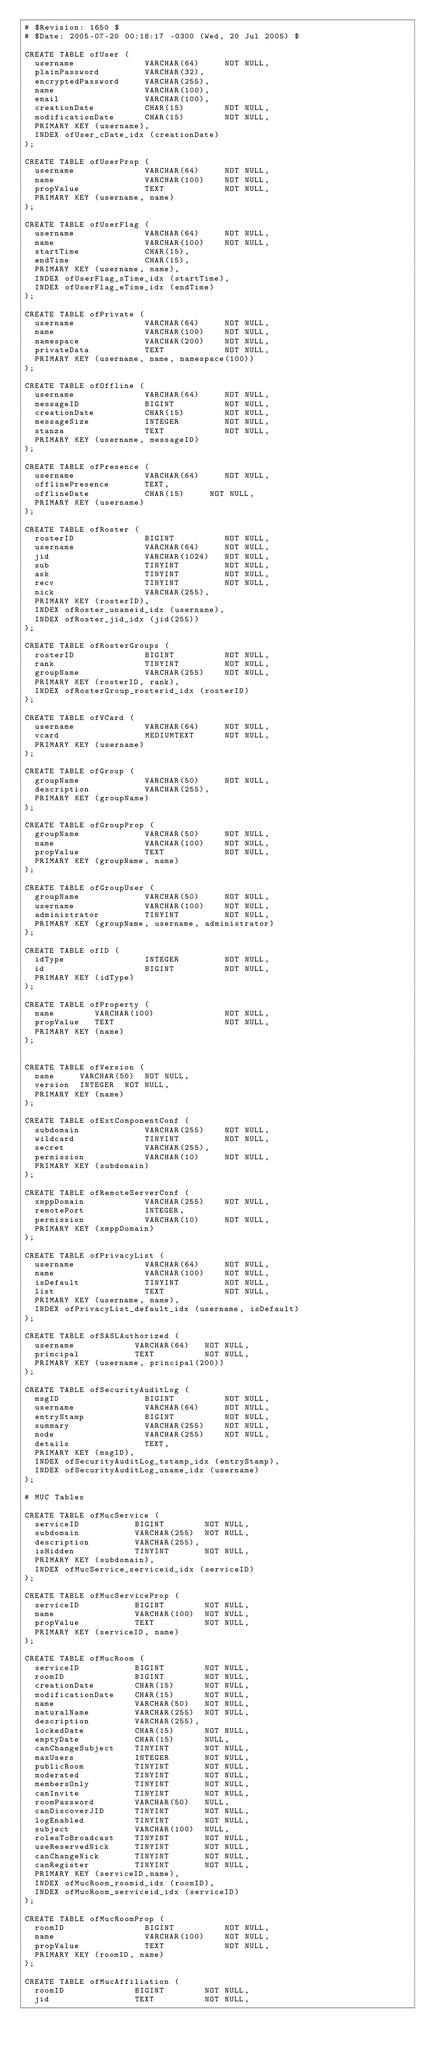Convert code to text. <code><loc_0><loc_0><loc_500><loc_500><_SQL_># $Revision: 1650 $
# $Date: 2005-07-20 00:18:17 -0300 (Wed, 20 Jul 2005) $

CREATE TABLE ofUser (
  username              VARCHAR(64)     NOT NULL,
  plainPassword         VARCHAR(32),
  encryptedPassword     VARCHAR(255),
  name                  VARCHAR(100),
  email                 VARCHAR(100),
  creationDate          CHAR(15)        NOT NULL,
  modificationDate      CHAR(15)        NOT NULL,
  PRIMARY KEY (username),
  INDEX ofUser_cDate_idx (creationDate)
);

CREATE TABLE ofUserProp (
  username              VARCHAR(64)     NOT NULL,
  name                  VARCHAR(100)    NOT NULL,
  propValue             TEXT            NOT NULL,
  PRIMARY KEY (username, name)
);

CREATE TABLE ofUserFlag (
  username              VARCHAR(64)     NOT NULL,
  name                  VARCHAR(100)    NOT NULL,
  startTime             CHAR(15),
  endTime               CHAR(15),
  PRIMARY KEY (username, name),
  INDEX ofUserFlag_sTime_idx (startTime),
  INDEX ofUserFlag_eTime_idx (endTime)
);

CREATE TABLE ofPrivate (
  username              VARCHAR(64)     NOT NULL,
  name                  VARCHAR(100)    NOT NULL,
  namespace             VARCHAR(200)    NOT NULL,
  privateData           TEXT            NOT NULL,
  PRIMARY KEY (username, name, namespace(100))
);

CREATE TABLE ofOffline (
  username              VARCHAR(64)     NOT NULL,
  messageID             BIGINT          NOT NULL,
  creationDate          CHAR(15)        NOT NULL,
  messageSize           INTEGER         NOT NULL,
  stanza                TEXT            NOT NULL,
  PRIMARY KEY (username, messageID)
);

CREATE TABLE ofPresence (
  username              VARCHAR(64)     NOT NULL,
  offlinePresence       TEXT,
  offlineDate           CHAR(15)     NOT NULL,
  PRIMARY KEY (username)
);

CREATE TABLE ofRoster (
  rosterID              BIGINT          NOT NULL,
  username              VARCHAR(64)     NOT NULL,
  jid                   VARCHAR(1024)   NOT NULL,
  sub                   TINYINT         NOT NULL,
  ask                   TINYINT         NOT NULL,
  recv                  TINYINT         NOT NULL,
  nick                  VARCHAR(255),
  PRIMARY KEY (rosterID),
  INDEX ofRoster_unameid_idx (username),
  INDEX ofRoster_jid_idx (jid(255))
);

CREATE TABLE ofRosterGroups (
  rosterID              BIGINT          NOT NULL,
  rank                  TINYINT         NOT NULL,
  groupName             VARCHAR(255)    NOT NULL,
  PRIMARY KEY (rosterID, rank),
  INDEX ofRosterGroup_rosterid_idx (rosterID)
);

CREATE TABLE ofVCard (
  username              VARCHAR(64)     NOT NULL,
  vcard                 MEDIUMTEXT      NOT NULL,
  PRIMARY KEY (username)
);

CREATE TABLE ofGroup (
  groupName             VARCHAR(50)     NOT NULL,
  description           VARCHAR(255),
  PRIMARY KEY (groupName)
);

CREATE TABLE ofGroupProp (
  groupName             VARCHAR(50)     NOT NULL,
  name                  VARCHAR(100)    NOT NULL,
  propValue             TEXT            NOT NULL,
  PRIMARY KEY (groupName, name)
);

CREATE TABLE ofGroupUser (
  groupName             VARCHAR(50)     NOT NULL,
  username              VARCHAR(100)    NOT NULL,
  administrator         TINYINT         NOT NULL,
  PRIMARY KEY (groupName, username, administrator)
);

CREATE TABLE ofID (
  idType                INTEGER         NOT NULL,
  id                    BIGINT          NOT NULL,
  PRIMARY KEY (idType)
);

CREATE TABLE ofProperty (
  name        VARCHAR(100)              NOT NULL,
  propValue   TEXT                      NOT NULL,
  PRIMARY KEY (name)
);


CREATE TABLE ofVersion (
  name     VARCHAR(50)  NOT NULL,
  version  INTEGER  NOT NULL,
  PRIMARY KEY (name)
);

CREATE TABLE ofExtComponentConf (
  subdomain             VARCHAR(255)    NOT NULL,
  wildcard              TINYINT         NOT NULL,
  secret                VARCHAR(255),
  permission            VARCHAR(10)     NOT NULL,
  PRIMARY KEY (subdomain)
);

CREATE TABLE ofRemoteServerConf (
  xmppDomain            VARCHAR(255)    NOT NULL,
  remotePort            INTEGER,
  permission            VARCHAR(10)     NOT NULL,
  PRIMARY KEY (xmppDomain)
);

CREATE TABLE ofPrivacyList (
  username              VARCHAR(64)     NOT NULL,
  name                  VARCHAR(100)    NOT NULL,
  isDefault             TINYINT         NOT NULL,
  list                  TEXT            NOT NULL,
  PRIMARY KEY (username, name),
  INDEX ofPrivacyList_default_idx (username, isDefault)
);

CREATE TABLE ofSASLAuthorized (
  username            VARCHAR(64)   NOT NULL,
  principal           TEXT          NOT NULL,
  PRIMARY KEY (username, principal(200))
);

CREATE TABLE ofSecurityAuditLog (
  msgID                 BIGINT          NOT NULL,
  username              VARCHAR(64)     NOT NULL,
  entryStamp            BIGINT          NOT NULL,
  summary               VARCHAR(255)    NOT NULL,
  node                  VARCHAR(255)    NOT NULL,
  details               TEXT,
  PRIMARY KEY (msgID),
  INDEX ofSecurityAuditLog_tstamp_idx (entryStamp),
  INDEX ofSecurityAuditLog_uname_idx (username)
);

# MUC Tables

CREATE TABLE ofMucService (
  serviceID           BIGINT        NOT NULL,
  subdomain           VARCHAR(255)  NOT NULL,
  description         VARCHAR(255),
  isHidden            TINYINT       NOT NULL,
  PRIMARY KEY (subdomain),
  INDEX ofMucService_serviceid_idx (serviceID)
);

CREATE TABLE ofMucServiceProp (
  serviceID           BIGINT        NOT NULL,
  name                VARCHAR(100)  NOT NULL,
  propValue           TEXT          NOT NULL,
  PRIMARY KEY (serviceID, name)
);

CREATE TABLE ofMucRoom (
  serviceID           BIGINT        NOT NULL,
  roomID              BIGINT        NOT NULL,
  creationDate        CHAR(15)      NOT NULL,
  modificationDate    CHAR(15)      NOT NULL,
  name                VARCHAR(50)   NOT NULL,
  naturalName         VARCHAR(255)  NOT NULL,
  description         VARCHAR(255),
  lockedDate          CHAR(15)      NOT NULL,
  emptyDate           CHAR(15)      NULL,
  canChangeSubject    TINYINT       NOT NULL,
  maxUsers            INTEGER       NOT NULL,
  publicRoom          TINYINT       NOT NULL,
  moderated           TINYINT       NOT NULL,
  membersOnly         TINYINT       NOT NULL,
  canInvite           TINYINT       NOT NULL,
  roomPassword        VARCHAR(50)   NULL,
  canDiscoverJID      TINYINT       NOT NULL,
  logEnabled          TINYINT       NOT NULL,
  subject             VARCHAR(100)  NULL,
  rolesToBroadcast    TINYINT       NOT NULL,
  useReservedNick     TINYINT       NOT NULL,
  canChangeNick       TINYINT       NOT NULL,
  canRegister         TINYINT       NOT NULL,
  PRIMARY KEY (serviceID,name),
  INDEX ofMucRoom_roomid_idx (roomID),
  INDEX ofMucRoom_serviceid_idx (serviceID)
);

CREATE TABLE ofMucRoomProp (
  roomID                BIGINT          NOT NULL,
  name                  VARCHAR(100)    NOT NULL,
  propValue             TEXT            NOT NULL,
  PRIMARY KEY (roomID, name)
);

CREATE TABLE ofMucAffiliation (
  roomID              BIGINT        NOT NULL,
  jid                 TEXT          NOT NULL,</code> 